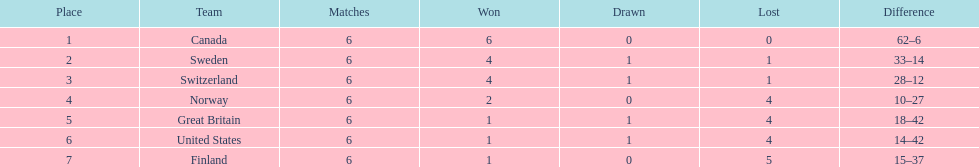What are the names of the countries? Canada, Sweden, Switzerland, Norway, Great Britain, United States, Finland. How many wins did switzerland have? 4. How many wins did great britain have? 1. Which country had more wins, great britain or switzerland? Switzerland. 